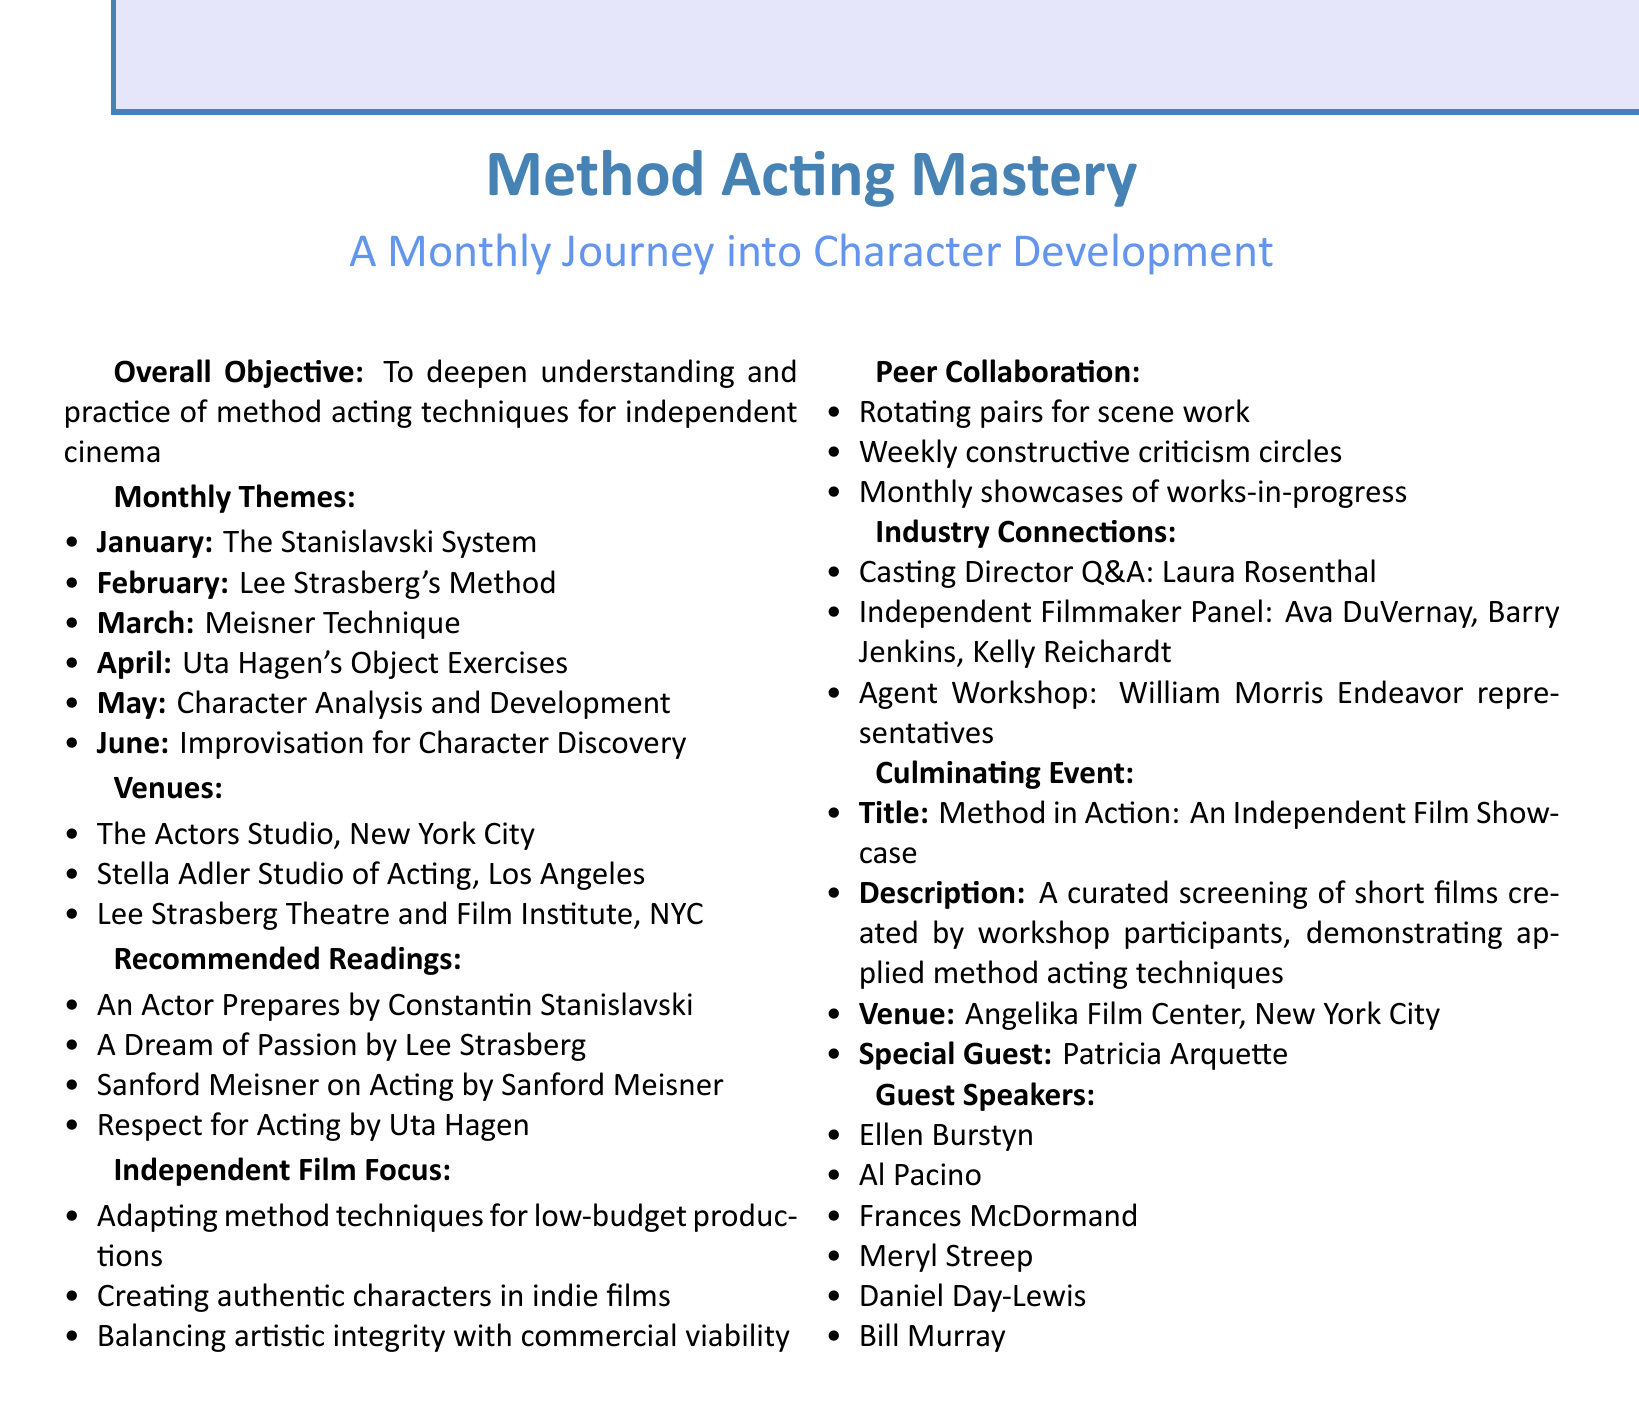what is the title of the workshop? The title of the workshop is presented at the beginning of the document.
Answer: Method Acting Mastery: A Monthly Journey into Character Development who is the guest speaker for February? The guest speakers for each month are listed alongside the monthly themes in the document.
Answer: Al Pacino what is the practical exercise for May? Each month's practical exercise is clearly specified under the corresponding theme, especially for May.
Answer: Creating detailed character biographies how many monthly themes are there in total? The total number of monthly themes can be counted from the list provided in the document.
Answer: Six what is the venue for the culminating event? The venue for the culminating event is explicitly mentioned in the description of the event in the document.
Answer: Angelika Film Center, New York City who is the discussion leader for balancing artistic integrity with commercial viability? This name can be found within the independent film focus section, detailing the discussion leaders for various topics.
Answer: Chloe Zhao which month focuses on improvisation techniques? The month focusing on improvisation techniques is specified among the monthly themes listed in the document.
Answer: June what type of collaboration is encouraged during the workshops? The document outlines a specific type of peer collaboration, highlighting different engagement strategies used.
Answer: Rotating pairs for scene work 